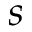Convert formula to latex. <formula><loc_0><loc_0><loc_500><loc_500>s</formula> 